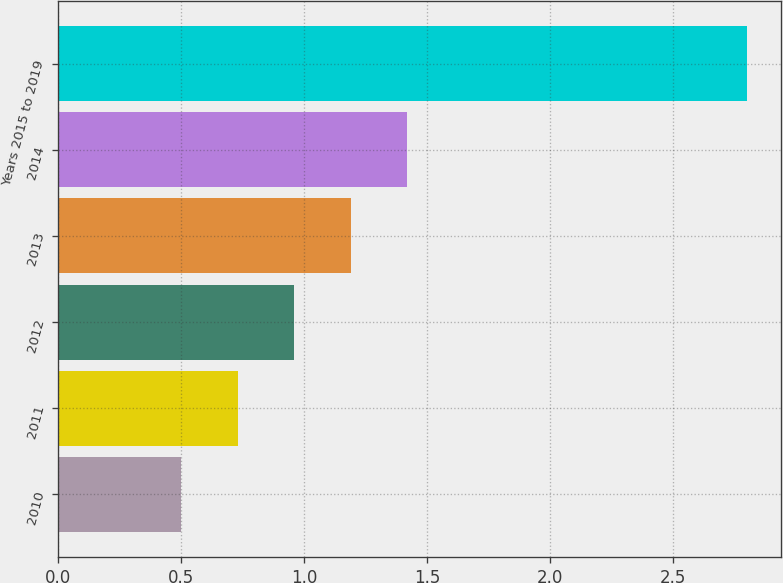Convert chart. <chart><loc_0><loc_0><loc_500><loc_500><bar_chart><fcel>2010<fcel>2011<fcel>2012<fcel>2013<fcel>2014<fcel>Years 2015 to 2019<nl><fcel>0.5<fcel>0.73<fcel>0.96<fcel>1.19<fcel>1.42<fcel>2.8<nl></chart> 